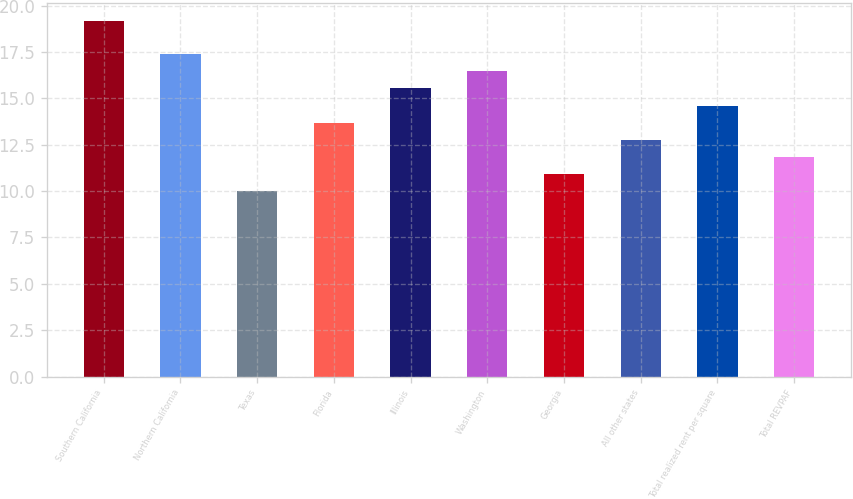Convert chart to OTSL. <chart><loc_0><loc_0><loc_500><loc_500><bar_chart><fcel>Southern California<fcel>Northern California<fcel>Texas<fcel>Florida<fcel>Illinois<fcel>Washington<fcel>Georgia<fcel>All other states<fcel>Total realized rent per square<fcel>Total REVPAF<nl><fcel>19.17<fcel>17.37<fcel>10.01<fcel>13.69<fcel>15.53<fcel>16.45<fcel>10.93<fcel>12.77<fcel>14.61<fcel>11.85<nl></chart> 